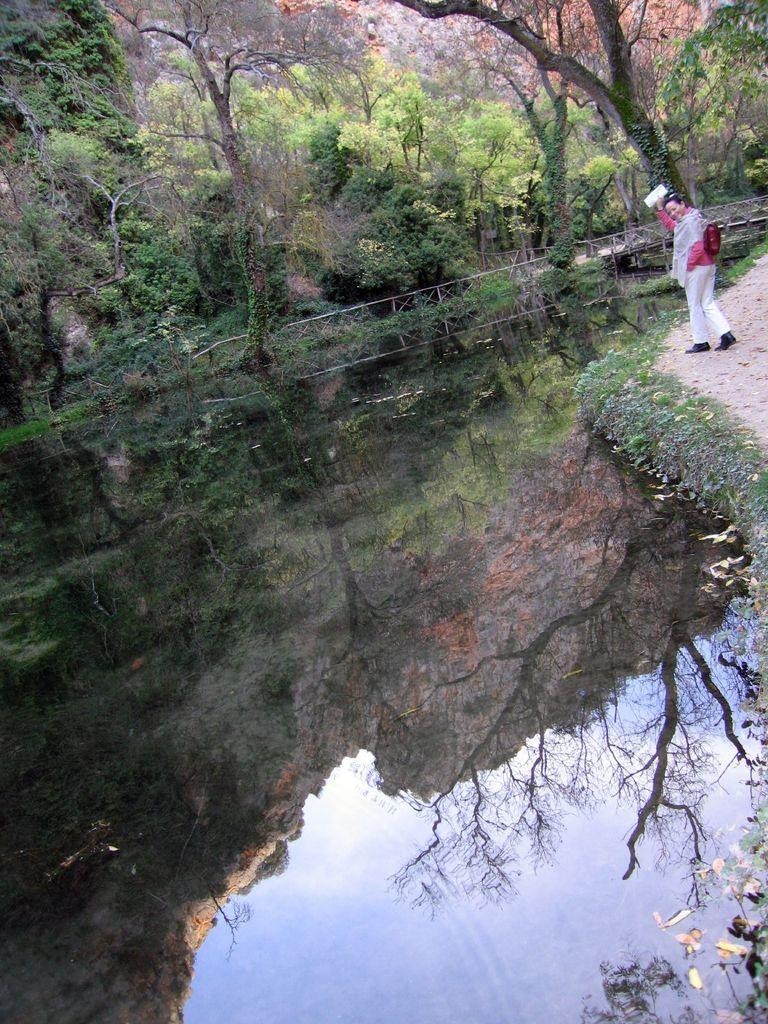What body of water is present in the image? There is a lake in the image. What is the woman in the image doing? A woman is walking on a path beside the lake. What type of vegetation surrounds the lake? There are trees around the lake. How can someone cross the lake in the image? There is a bridge constructed across the lake. What type of nail is the minister using to fix the bridge in the image? There is no minister or nail present in the image, and the bridge is already constructed. 